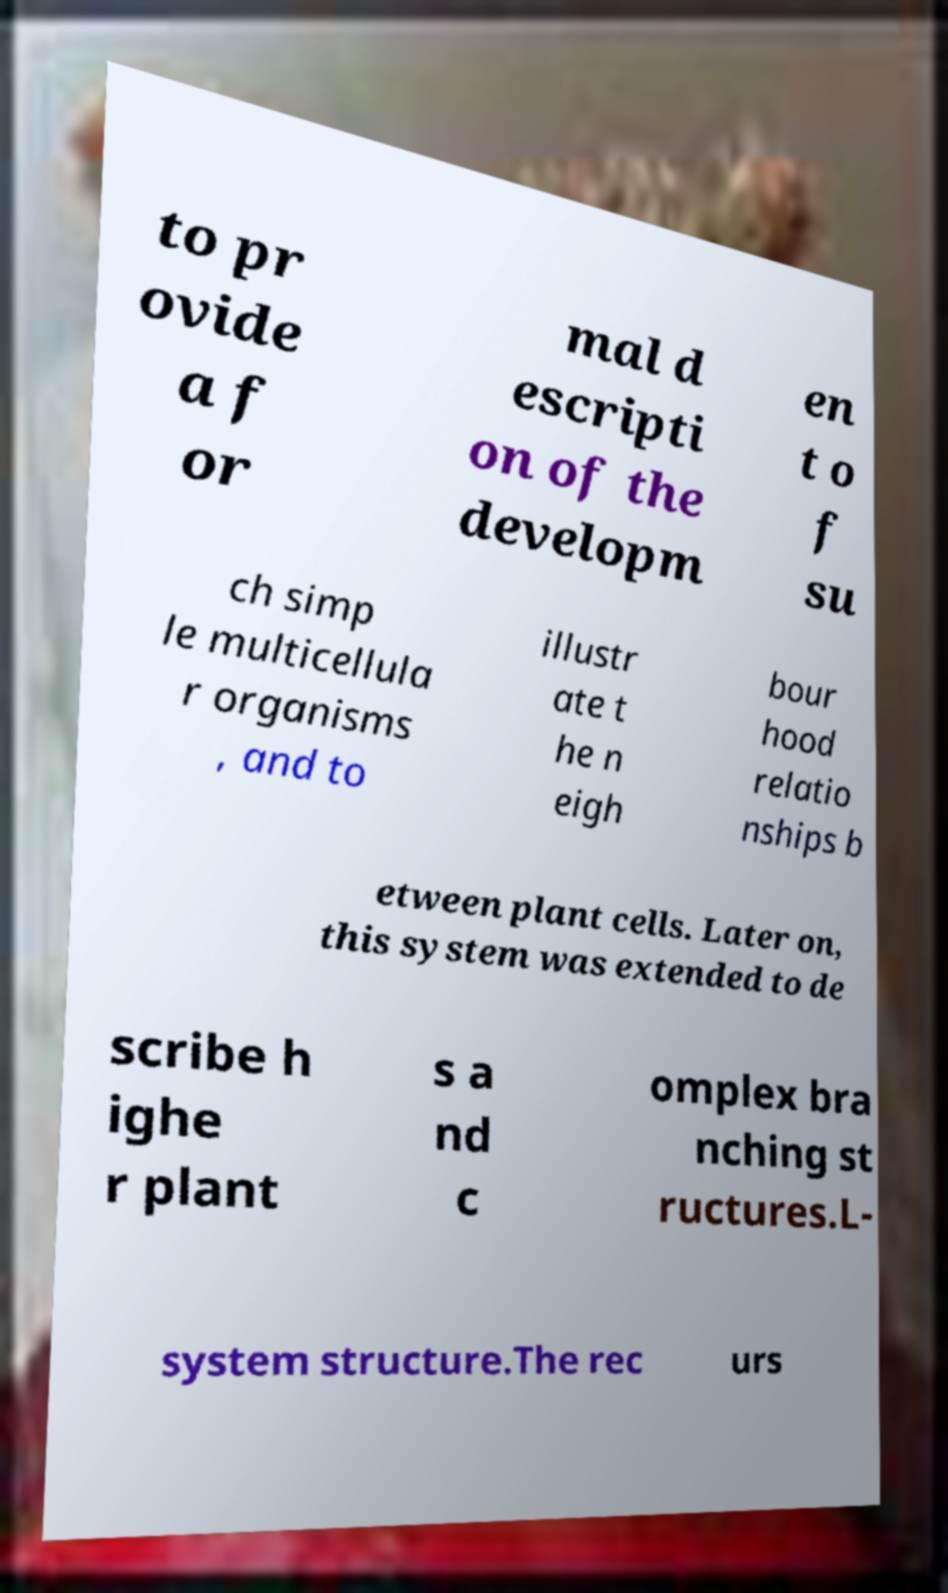For documentation purposes, I need the text within this image transcribed. Could you provide that? to pr ovide a f or mal d escripti on of the developm en t o f su ch simp le multicellula r organisms , and to illustr ate t he n eigh bour hood relatio nships b etween plant cells. Later on, this system was extended to de scribe h ighe r plant s a nd c omplex bra nching st ructures.L- system structure.The rec urs 